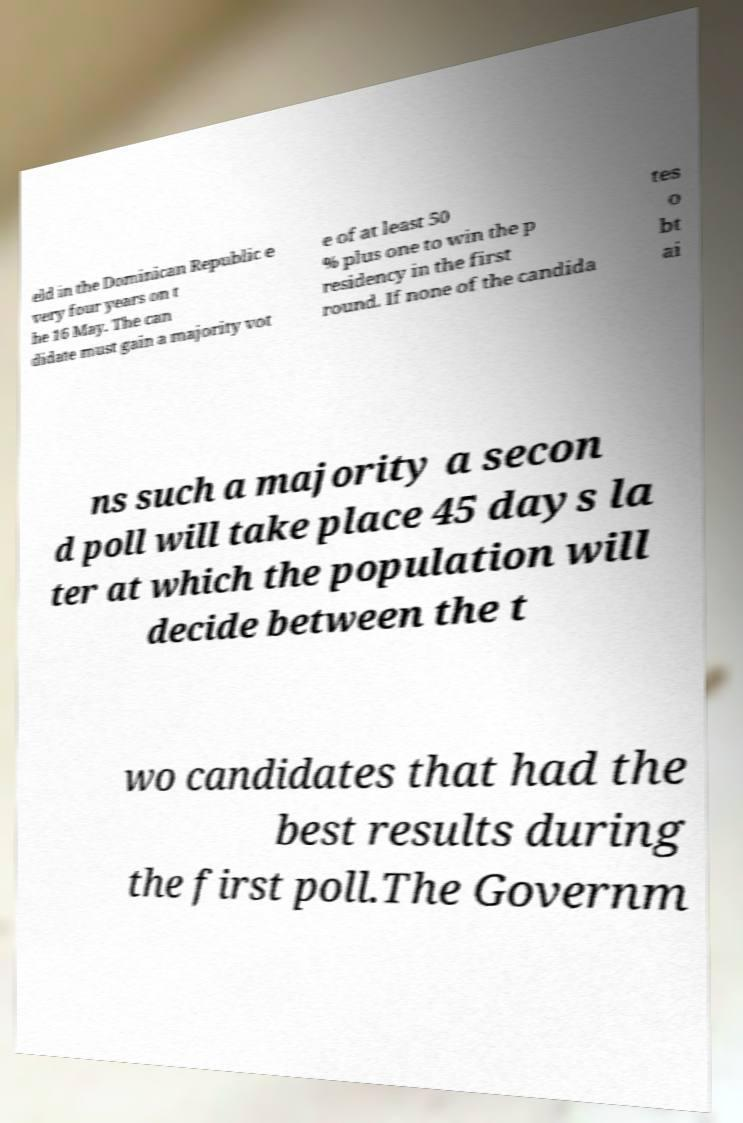Please identify and transcribe the text found in this image. eld in the Dominican Republic e very four years on t he 16 May. The can didate must gain a majority vot e of at least 50 % plus one to win the p residency in the first round. If none of the candida tes o bt ai ns such a majority a secon d poll will take place 45 days la ter at which the population will decide between the t wo candidates that had the best results during the first poll.The Governm 